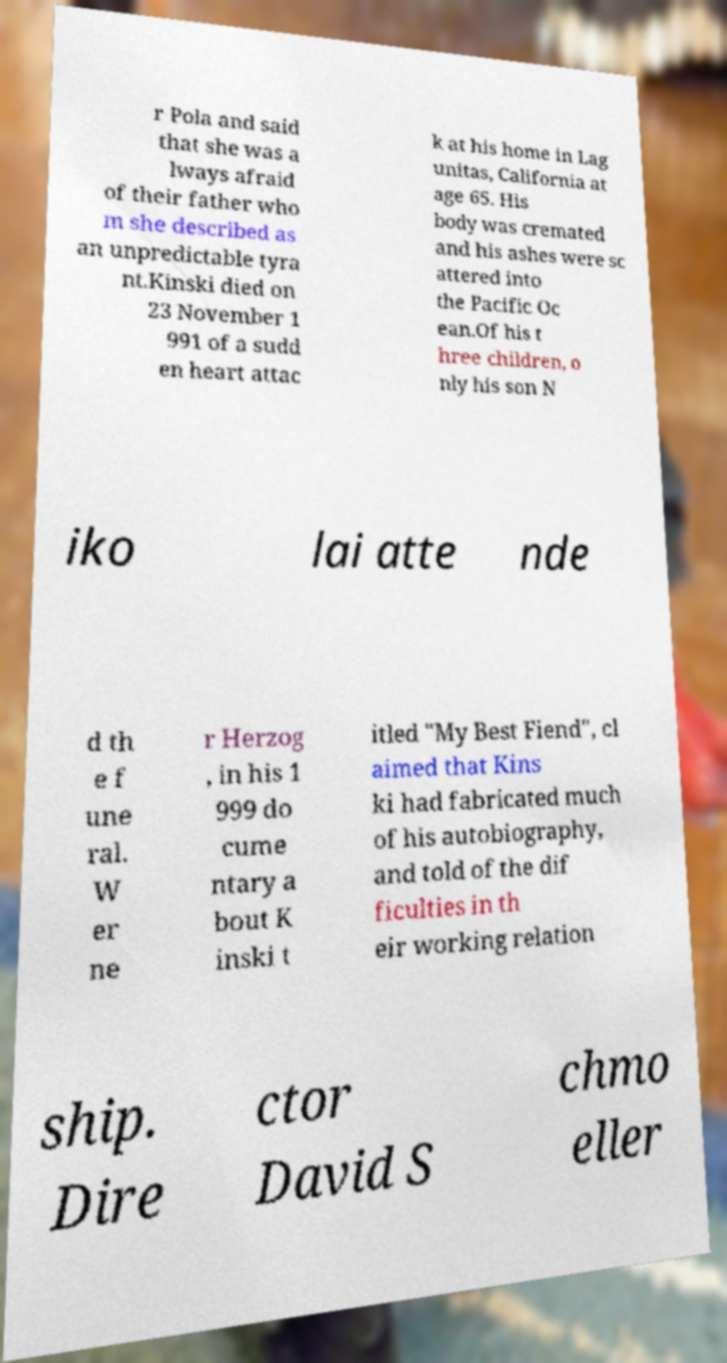Can you read and provide the text displayed in the image?This photo seems to have some interesting text. Can you extract and type it out for me? r Pola and said that she was a lways afraid of their father who m she described as an unpredictable tyra nt.Kinski died on 23 November 1 991 of a sudd en heart attac k at his home in Lag unitas, California at age 65. His body was cremated and his ashes were sc attered into the Pacific Oc ean.Of his t hree children, o nly his son N iko lai atte nde d th e f une ral. W er ne r Herzog , in his 1 999 do cume ntary a bout K inski t itled "My Best Fiend", cl aimed that Kins ki had fabricated much of his autobiography, and told of the dif ficulties in th eir working relation ship. Dire ctor David S chmo eller 